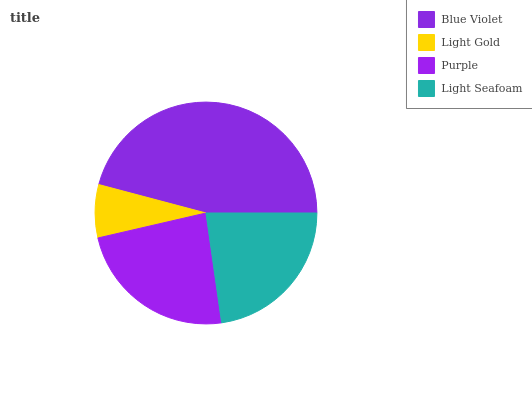Is Light Gold the minimum?
Answer yes or no. Yes. Is Blue Violet the maximum?
Answer yes or no. Yes. Is Purple the minimum?
Answer yes or no. No. Is Purple the maximum?
Answer yes or no. No. Is Purple greater than Light Gold?
Answer yes or no. Yes. Is Light Gold less than Purple?
Answer yes or no. Yes. Is Light Gold greater than Purple?
Answer yes or no. No. Is Purple less than Light Gold?
Answer yes or no. No. Is Purple the high median?
Answer yes or no. Yes. Is Light Seafoam the low median?
Answer yes or no. Yes. Is Blue Violet the high median?
Answer yes or no. No. Is Light Gold the low median?
Answer yes or no. No. 